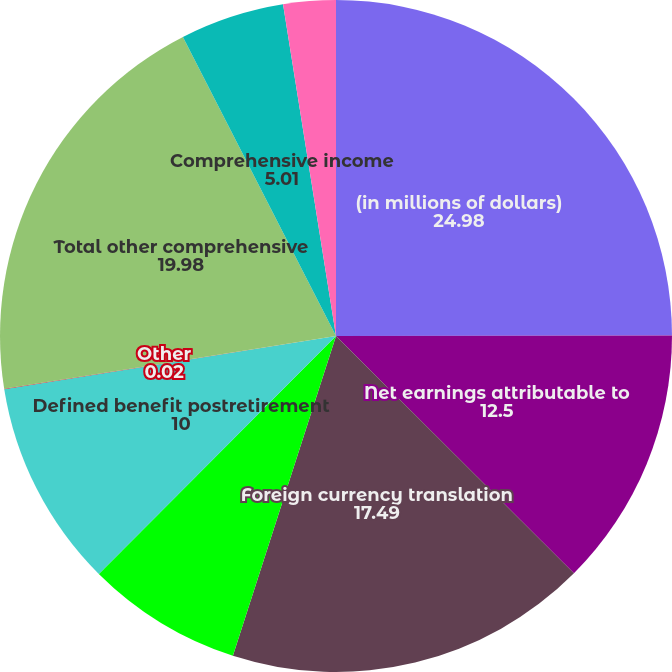<chart> <loc_0><loc_0><loc_500><loc_500><pie_chart><fcel>(in millions of dollars)<fcel>Net earnings attributable to<fcel>Foreign currency translation<fcel>Hedge instruments<fcel>Defined benefit postretirement<fcel>Other<fcel>Total other comprehensive<fcel>Comprehensive income<fcel>Other comprehensive income<nl><fcel>24.98%<fcel>12.5%<fcel>17.49%<fcel>7.51%<fcel>10.0%<fcel>0.02%<fcel>19.98%<fcel>5.01%<fcel>2.52%<nl></chart> 